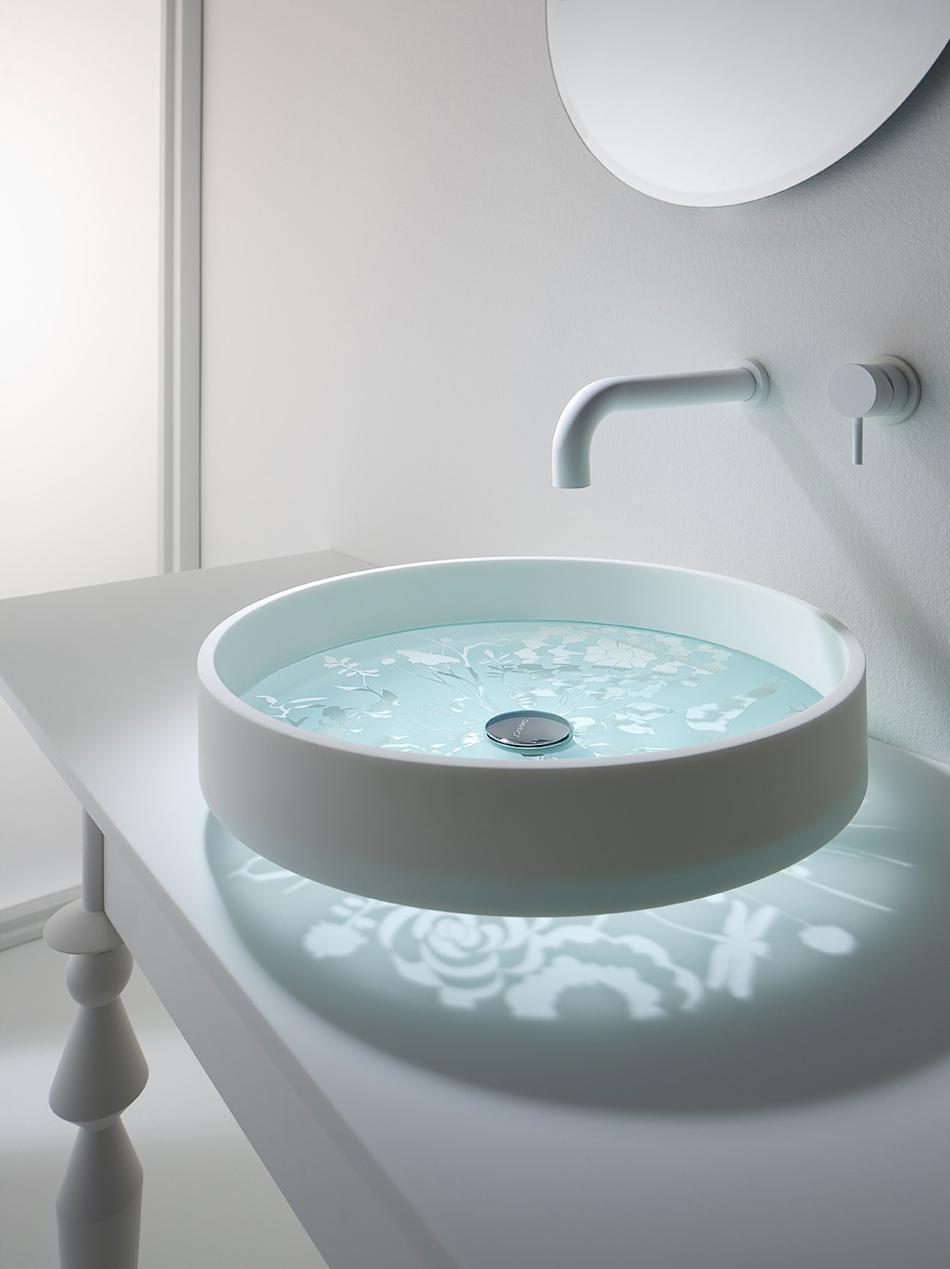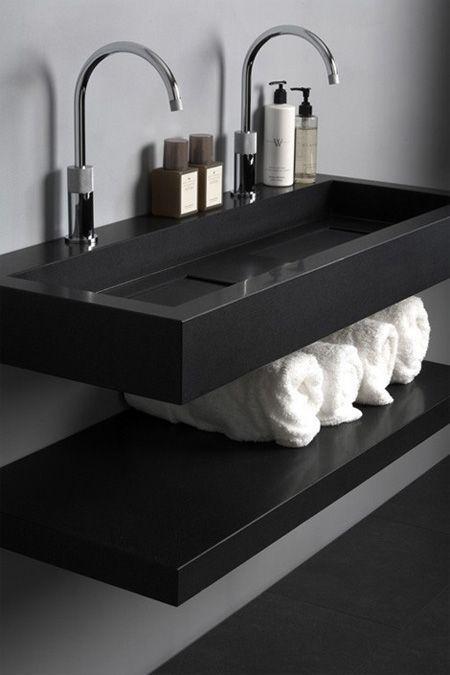The first image is the image on the left, the second image is the image on the right. For the images displayed, is the sentence "A thin stream of water is flowing into a sink that sits atop a dark wood counter in one image." factually correct? Answer yes or no. No. The first image is the image on the left, the second image is the image on the right. Given the left and right images, does the statement "A round mirror is above a sink." hold true? Answer yes or no. Yes. 